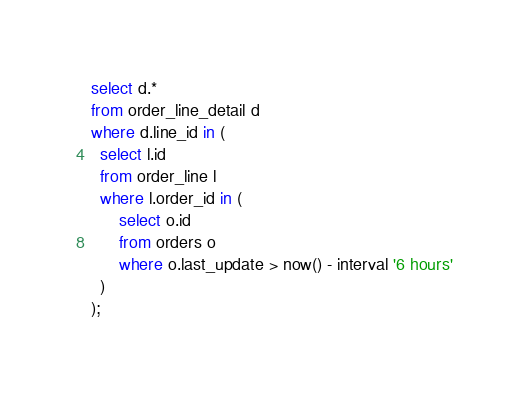<code> <loc_0><loc_0><loc_500><loc_500><_SQL_>select d.*
from order_line_detail d
where d.line_id in (
  select l.id
  from order_line l
  where l.order_id in (
      select o.id
      from orders o
      where o.last_update > now() - interval '6 hours'
  )
);
</code> 